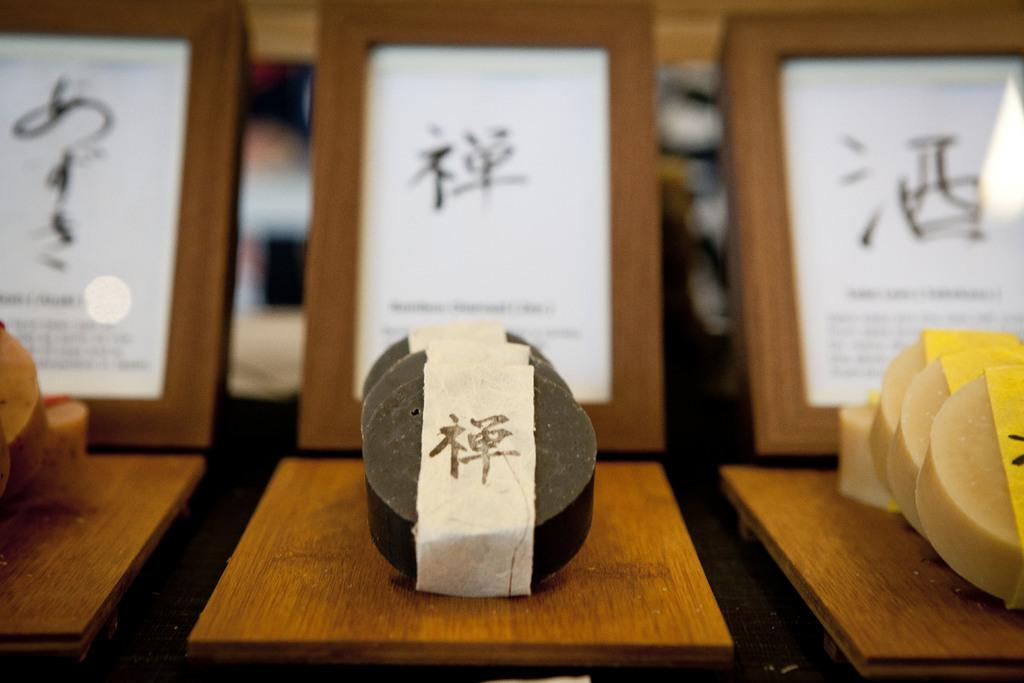What type of objects can be seen in the image? There are food items in the image. What is the color of the surface on which the food items are placed? The food items are on a brown color surface. Can you describe anything in the background of the image? The background of the image features blurry boards. Is there a toad sitting on top of the food items in the image? No, there is no toad present in the image. 